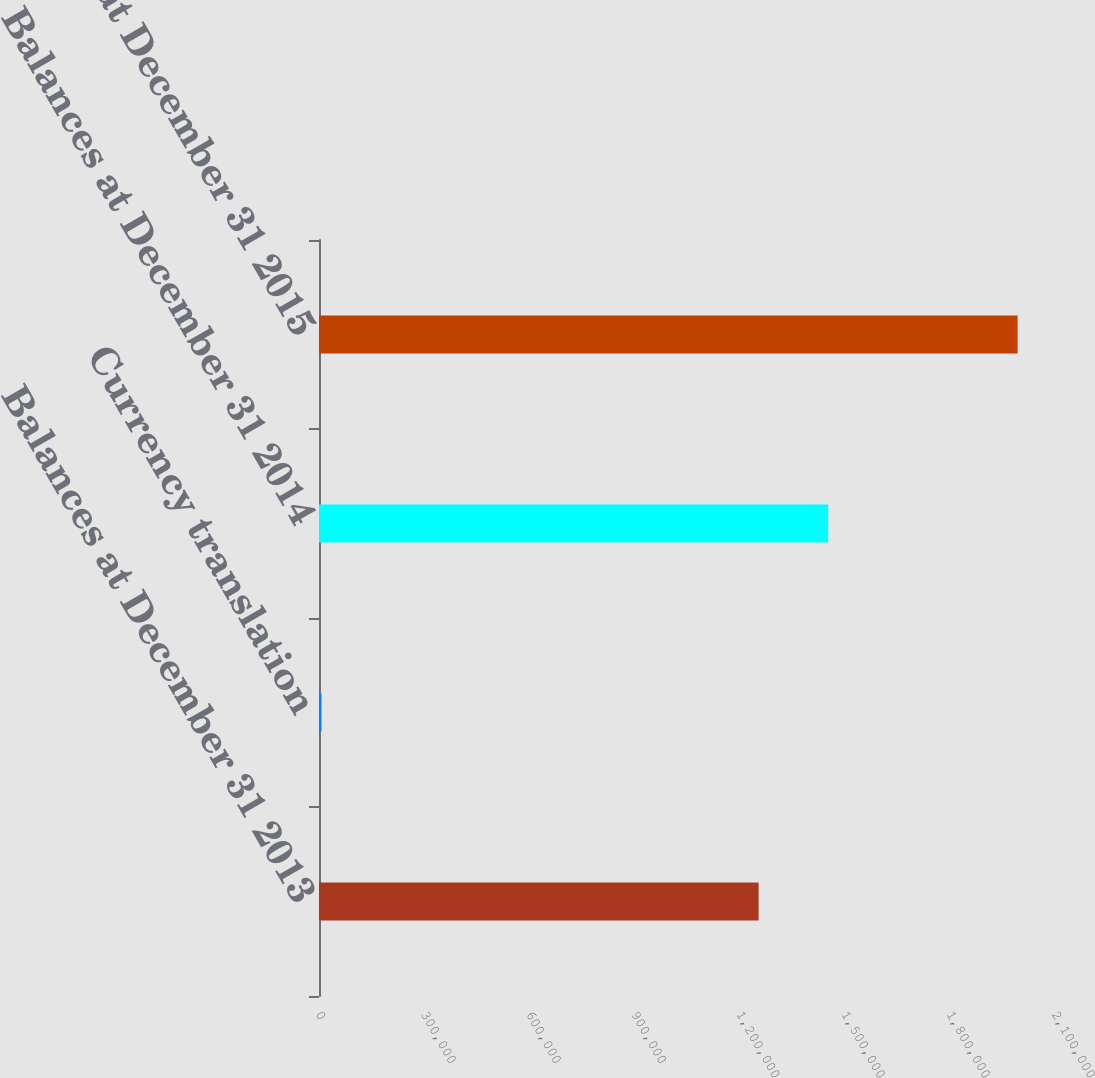Convert chart to OTSL. <chart><loc_0><loc_0><loc_500><loc_500><bar_chart><fcel>Balances at December 31 2013<fcel>Currency translation<fcel>Balances at December 31 2014<fcel>Balances at December 31 2015<nl><fcel>1.25429e+06<fcel>7102<fcel>1.45291e+06<fcel>1.9933e+06<nl></chart> 